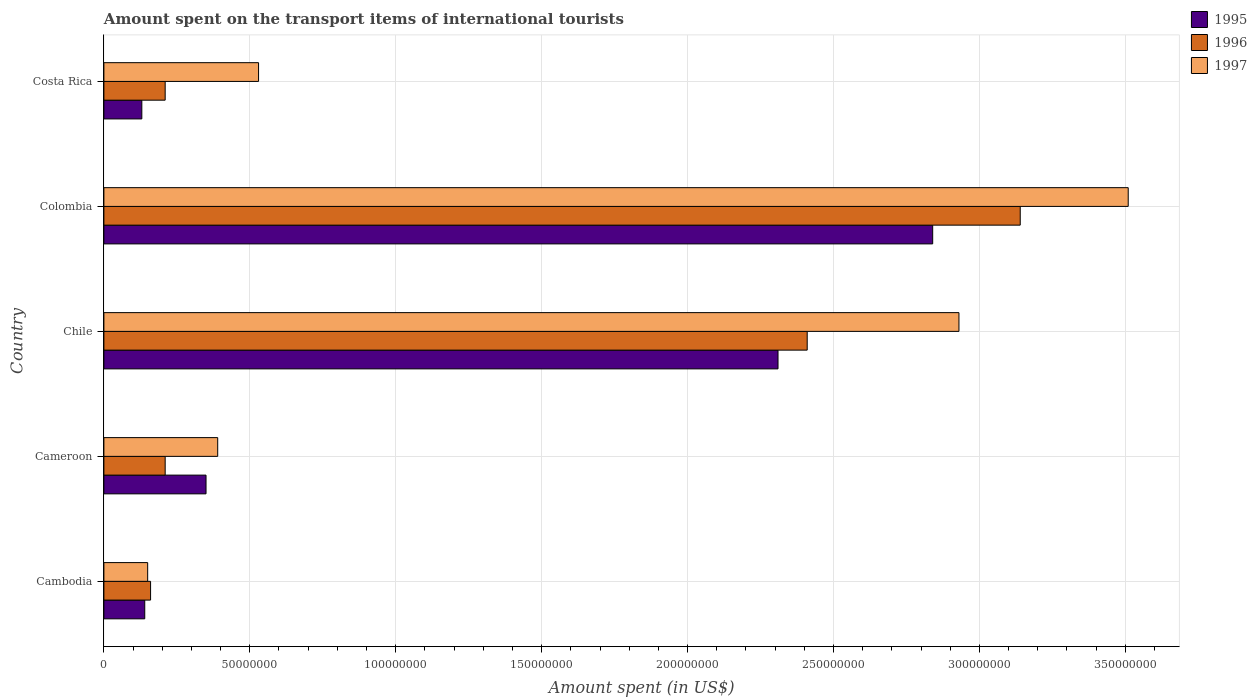How many different coloured bars are there?
Your answer should be compact. 3. How many groups of bars are there?
Keep it short and to the point. 5. Are the number of bars per tick equal to the number of legend labels?
Provide a short and direct response. Yes. Are the number of bars on each tick of the Y-axis equal?
Your response must be concise. Yes. How many bars are there on the 2nd tick from the top?
Make the answer very short. 3. What is the label of the 3rd group of bars from the top?
Give a very brief answer. Chile. What is the amount spent on the transport items of international tourists in 1997 in Costa Rica?
Provide a short and direct response. 5.30e+07. Across all countries, what is the maximum amount spent on the transport items of international tourists in 1997?
Keep it short and to the point. 3.51e+08. Across all countries, what is the minimum amount spent on the transport items of international tourists in 1997?
Make the answer very short. 1.50e+07. What is the total amount spent on the transport items of international tourists in 1997 in the graph?
Provide a succinct answer. 7.51e+08. What is the difference between the amount spent on the transport items of international tourists in 1997 in Cambodia and that in Colombia?
Your answer should be very brief. -3.36e+08. What is the difference between the amount spent on the transport items of international tourists in 1997 in Chile and the amount spent on the transport items of international tourists in 1995 in Cambodia?
Your answer should be very brief. 2.79e+08. What is the average amount spent on the transport items of international tourists in 1996 per country?
Your response must be concise. 1.23e+08. What is the difference between the amount spent on the transport items of international tourists in 1995 and amount spent on the transport items of international tourists in 1997 in Chile?
Provide a short and direct response. -6.20e+07. What is the ratio of the amount spent on the transport items of international tourists in 1996 in Chile to that in Costa Rica?
Offer a terse response. 11.48. What is the difference between the highest and the second highest amount spent on the transport items of international tourists in 1997?
Make the answer very short. 5.80e+07. What is the difference between the highest and the lowest amount spent on the transport items of international tourists in 1997?
Make the answer very short. 3.36e+08. In how many countries, is the amount spent on the transport items of international tourists in 1996 greater than the average amount spent on the transport items of international tourists in 1996 taken over all countries?
Your answer should be compact. 2. Is the sum of the amount spent on the transport items of international tourists in 1996 in Cambodia and Chile greater than the maximum amount spent on the transport items of international tourists in 1995 across all countries?
Give a very brief answer. No. What does the 1st bar from the bottom in Cameroon represents?
Give a very brief answer. 1995. How many bars are there?
Give a very brief answer. 15. What is the difference between two consecutive major ticks on the X-axis?
Your answer should be compact. 5.00e+07. Does the graph contain grids?
Your response must be concise. Yes. How many legend labels are there?
Ensure brevity in your answer.  3. What is the title of the graph?
Give a very brief answer. Amount spent on the transport items of international tourists. Does "2006" appear as one of the legend labels in the graph?
Your answer should be very brief. No. What is the label or title of the X-axis?
Your answer should be compact. Amount spent (in US$). What is the label or title of the Y-axis?
Keep it short and to the point. Country. What is the Amount spent (in US$) of 1995 in Cambodia?
Your answer should be very brief. 1.40e+07. What is the Amount spent (in US$) in 1996 in Cambodia?
Your response must be concise. 1.60e+07. What is the Amount spent (in US$) of 1997 in Cambodia?
Offer a very short reply. 1.50e+07. What is the Amount spent (in US$) in 1995 in Cameroon?
Offer a terse response. 3.50e+07. What is the Amount spent (in US$) of 1996 in Cameroon?
Your answer should be very brief. 2.10e+07. What is the Amount spent (in US$) of 1997 in Cameroon?
Offer a terse response. 3.90e+07. What is the Amount spent (in US$) in 1995 in Chile?
Your answer should be very brief. 2.31e+08. What is the Amount spent (in US$) in 1996 in Chile?
Ensure brevity in your answer.  2.41e+08. What is the Amount spent (in US$) in 1997 in Chile?
Offer a terse response. 2.93e+08. What is the Amount spent (in US$) in 1995 in Colombia?
Provide a short and direct response. 2.84e+08. What is the Amount spent (in US$) in 1996 in Colombia?
Offer a terse response. 3.14e+08. What is the Amount spent (in US$) of 1997 in Colombia?
Offer a terse response. 3.51e+08. What is the Amount spent (in US$) of 1995 in Costa Rica?
Ensure brevity in your answer.  1.30e+07. What is the Amount spent (in US$) in 1996 in Costa Rica?
Your response must be concise. 2.10e+07. What is the Amount spent (in US$) in 1997 in Costa Rica?
Your response must be concise. 5.30e+07. Across all countries, what is the maximum Amount spent (in US$) in 1995?
Give a very brief answer. 2.84e+08. Across all countries, what is the maximum Amount spent (in US$) of 1996?
Your answer should be compact. 3.14e+08. Across all countries, what is the maximum Amount spent (in US$) in 1997?
Offer a very short reply. 3.51e+08. Across all countries, what is the minimum Amount spent (in US$) in 1995?
Offer a terse response. 1.30e+07. Across all countries, what is the minimum Amount spent (in US$) of 1996?
Offer a terse response. 1.60e+07. Across all countries, what is the minimum Amount spent (in US$) of 1997?
Offer a terse response. 1.50e+07. What is the total Amount spent (in US$) in 1995 in the graph?
Your response must be concise. 5.77e+08. What is the total Amount spent (in US$) in 1996 in the graph?
Offer a very short reply. 6.13e+08. What is the total Amount spent (in US$) of 1997 in the graph?
Keep it short and to the point. 7.51e+08. What is the difference between the Amount spent (in US$) of 1995 in Cambodia and that in Cameroon?
Offer a very short reply. -2.10e+07. What is the difference between the Amount spent (in US$) in 1996 in Cambodia and that in Cameroon?
Offer a terse response. -5.00e+06. What is the difference between the Amount spent (in US$) of 1997 in Cambodia and that in Cameroon?
Your answer should be compact. -2.40e+07. What is the difference between the Amount spent (in US$) in 1995 in Cambodia and that in Chile?
Offer a terse response. -2.17e+08. What is the difference between the Amount spent (in US$) in 1996 in Cambodia and that in Chile?
Your answer should be very brief. -2.25e+08. What is the difference between the Amount spent (in US$) of 1997 in Cambodia and that in Chile?
Provide a succinct answer. -2.78e+08. What is the difference between the Amount spent (in US$) in 1995 in Cambodia and that in Colombia?
Offer a very short reply. -2.70e+08. What is the difference between the Amount spent (in US$) in 1996 in Cambodia and that in Colombia?
Offer a terse response. -2.98e+08. What is the difference between the Amount spent (in US$) of 1997 in Cambodia and that in Colombia?
Keep it short and to the point. -3.36e+08. What is the difference between the Amount spent (in US$) in 1996 in Cambodia and that in Costa Rica?
Provide a succinct answer. -5.00e+06. What is the difference between the Amount spent (in US$) in 1997 in Cambodia and that in Costa Rica?
Your answer should be very brief. -3.80e+07. What is the difference between the Amount spent (in US$) of 1995 in Cameroon and that in Chile?
Offer a terse response. -1.96e+08. What is the difference between the Amount spent (in US$) of 1996 in Cameroon and that in Chile?
Your response must be concise. -2.20e+08. What is the difference between the Amount spent (in US$) in 1997 in Cameroon and that in Chile?
Offer a terse response. -2.54e+08. What is the difference between the Amount spent (in US$) in 1995 in Cameroon and that in Colombia?
Ensure brevity in your answer.  -2.49e+08. What is the difference between the Amount spent (in US$) of 1996 in Cameroon and that in Colombia?
Your answer should be very brief. -2.93e+08. What is the difference between the Amount spent (in US$) in 1997 in Cameroon and that in Colombia?
Offer a very short reply. -3.12e+08. What is the difference between the Amount spent (in US$) of 1995 in Cameroon and that in Costa Rica?
Your response must be concise. 2.20e+07. What is the difference between the Amount spent (in US$) of 1997 in Cameroon and that in Costa Rica?
Offer a very short reply. -1.40e+07. What is the difference between the Amount spent (in US$) of 1995 in Chile and that in Colombia?
Ensure brevity in your answer.  -5.30e+07. What is the difference between the Amount spent (in US$) in 1996 in Chile and that in Colombia?
Give a very brief answer. -7.30e+07. What is the difference between the Amount spent (in US$) of 1997 in Chile and that in Colombia?
Your answer should be very brief. -5.80e+07. What is the difference between the Amount spent (in US$) of 1995 in Chile and that in Costa Rica?
Offer a very short reply. 2.18e+08. What is the difference between the Amount spent (in US$) in 1996 in Chile and that in Costa Rica?
Your answer should be compact. 2.20e+08. What is the difference between the Amount spent (in US$) in 1997 in Chile and that in Costa Rica?
Ensure brevity in your answer.  2.40e+08. What is the difference between the Amount spent (in US$) of 1995 in Colombia and that in Costa Rica?
Make the answer very short. 2.71e+08. What is the difference between the Amount spent (in US$) of 1996 in Colombia and that in Costa Rica?
Offer a terse response. 2.93e+08. What is the difference between the Amount spent (in US$) of 1997 in Colombia and that in Costa Rica?
Your answer should be very brief. 2.98e+08. What is the difference between the Amount spent (in US$) of 1995 in Cambodia and the Amount spent (in US$) of 1996 in Cameroon?
Provide a succinct answer. -7.00e+06. What is the difference between the Amount spent (in US$) of 1995 in Cambodia and the Amount spent (in US$) of 1997 in Cameroon?
Give a very brief answer. -2.50e+07. What is the difference between the Amount spent (in US$) of 1996 in Cambodia and the Amount spent (in US$) of 1997 in Cameroon?
Offer a very short reply. -2.30e+07. What is the difference between the Amount spent (in US$) of 1995 in Cambodia and the Amount spent (in US$) of 1996 in Chile?
Make the answer very short. -2.27e+08. What is the difference between the Amount spent (in US$) of 1995 in Cambodia and the Amount spent (in US$) of 1997 in Chile?
Provide a succinct answer. -2.79e+08. What is the difference between the Amount spent (in US$) in 1996 in Cambodia and the Amount spent (in US$) in 1997 in Chile?
Offer a terse response. -2.77e+08. What is the difference between the Amount spent (in US$) of 1995 in Cambodia and the Amount spent (in US$) of 1996 in Colombia?
Provide a succinct answer. -3.00e+08. What is the difference between the Amount spent (in US$) of 1995 in Cambodia and the Amount spent (in US$) of 1997 in Colombia?
Your answer should be very brief. -3.37e+08. What is the difference between the Amount spent (in US$) in 1996 in Cambodia and the Amount spent (in US$) in 1997 in Colombia?
Your response must be concise. -3.35e+08. What is the difference between the Amount spent (in US$) in 1995 in Cambodia and the Amount spent (in US$) in 1996 in Costa Rica?
Ensure brevity in your answer.  -7.00e+06. What is the difference between the Amount spent (in US$) of 1995 in Cambodia and the Amount spent (in US$) of 1997 in Costa Rica?
Ensure brevity in your answer.  -3.90e+07. What is the difference between the Amount spent (in US$) in 1996 in Cambodia and the Amount spent (in US$) in 1997 in Costa Rica?
Make the answer very short. -3.70e+07. What is the difference between the Amount spent (in US$) of 1995 in Cameroon and the Amount spent (in US$) of 1996 in Chile?
Ensure brevity in your answer.  -2.06e+08. What is the difference between the Amount spent (in US$) of 1995 in Cameroon and the Amount spent (in US$) of 1997 in Chile?
Make the answer very short. -2.58e+08. What is the difference between the Amount spent (in US$) in 1996 in Cameroon and the Amount spent (in US$) in 1997 in Chile?
Provide a short and direct response. -2.72e+08. What is the difference between the Amount spent (in US$) of 1995 in Cameroon and the Amount spent (in US$) of 1996 in Colombia?
Your answer should be very brief. -2.79e+08. What is the difference between the Amount spent (in US$) in 1995 in Cameroon and the Amount spent (in US$) in 1997 in Colombia?
Ensure brevity in your answer.  -3.16e+08. What is the difference between the Amount spent (in US$) in 1996 in Cameroon and the Amount spent (in US$) in 1997 in Colombia?
Ensure brevity in your answer.  -3.30e+08. What is the difference between the Amount spent (in US$) of 1995 in Cameroon and the Amount spent (in US$) of 1996 in Costa Rica?
Offer a very short reply. 1.40e+07. What is the difference between the Amount spent (in US$) of 1995 in Cameroon and the Amount spent (in US$) of 1997 in Costa Rica?
Your response must be concise. -1.80e+07. What is the difference between the Amount spent (in US$) in 1996 in Cameroon and the Amount spent (in US$) in 1997 in Costa Rica?
Offer a very short reply. -3.20e+07. What is the difference between the Amount spent (in US$) in 1995 in Chile and the Amount spent (in US$) in 1996 in Colombia?
Your response must be concise. -8.30e+07. What is the difference between the Amount spent (in US$) of 1995 in Chile and the Amount spent (in US$) of 1997 in Colombia?
Ensure brevity in your answer.  -1.20e+08. What is the difference between the Amount spent (in US$) of 1996 in Chile and the Amount spent (in US$) of 1997 in Colombia?
Offer a terse response. -1.10e+08. What is the difference between the Amount spent (in US$) of 1995 in Chile and the Amount spent (in US$) of 1996 in Costa Rica?
Give a very brief answer. 2.10e+08. What is the difference between the Amount spent (in US$) in 1995 in Chile and the Amount spent (in US$) in 1997 in Costa Rica?
Make the answer very short. 1.78e+08. What is the difference between the Amount spent (in US$) of 1996 in Chile and the Amount spent (in US$) of 1997 in Costa Rica?
Your response must be concise. 1.88e+08. What is the difference between the Amount spent (in US$) in 1995 in Colombia and the Amount spent (in US$) in 1996 in Costa Rica?
Give a very brief answer. 2.63e+08. What is the difference between the Amount spent (in US$) in 1995 in Colombia and the Amount spent (in US$) in 1997 in Costa Rica?
Your response must be concise. 2.31e+08. What is the difference between the Amount spent (in US$) in 1996 in Colombia and the Amount spent (in US$) in 1997 in Costa Rica?
Your answer should be very brief. 2.61e+08. What is the average Amount spent (in US$) in 1995 per country?
Provide a short and direct response. 1.15e+08. What is the average Amount spent (in US$) of 1996 per country?
Make the answer very short. 1.23e+08. What is the average Amount spent (in US$) in 1997 per country?
Your response must be concise. 1.50e+08. What is the difference between the Amount spent (in US$) of 1996 and Amount spent (in US$) of 1997 in Cambodia?
Your answer should be compact. 1.00e+06. What is the difference between the Amount spent (in US$) of 1995 and Amount spent (in US$) of 1996 in Cameroon?
Your response must be concise. 1.40e+07. What is the difference between the Amount spent (in US$) of 1996 and Amount spent (in US$) of 1997 in Cameroon?
Offer a very short reply. -1.80e+07. What is the difference between the Amount spent (in US$) of 1995 and Amount spent (in US$) of 1996 in Chile?
Your answer should be compact. -1.00e+07. What is the difference between the Amount spent (in US$) of 1995 and Amount spent (in US$) of 1997 in Chile?
Your response must be concise. -6.20e+07. What is the difference between the Amount spent (in US$) in 1996 and Amount spent (in US$) in 1997 in Chile?
Make the answer very short. -5.20e+07. What is the difference between the Amount spent (in US$) in 1995 and Amount spent (in US$) in 1996 in Colombia?
Keep it short and to the point. -3.00e+07. What is the difference between the Amount spent (in US$) of 1995 and Amount spent (in US$) of 1997 in Colombia?
Keep it short and to the point. -6.70e+07. What is the difference between the Amount spent (in US$) in 1996 and Amount spent (in US$) in 1997 in Colombia?
Give a very brief answer. -3.70e+07. What is the difference between the Amount spent (in US$) of 1995 and Amount spent (in US$) of 1996 in Costa Rica?
Your answer should be compact. -8.00e+06. What is the difference between the Amount spent (in US$) in 1995 and Amount spent (in US$) in 1997 in Costa Rica?
Keep it short and to the point. -4.00e+07. What is the difference between the Amount spent (in US$) of 1996 and Amount spent (in US$) of 1997 in Costa Rica?
Offer a terse response. -3.20e+07. What is the ratio of the Amount spent (in US$) in 1996 in Cambodia to that in Cameroon?
Offer a very short reply. 0.76. What is the ratio of the Amount spent (in US$) of 1997 in Cambodia to that in Cameroon?
Ensure brevity in your answer.  0.38. What is the ratio of the Amount spent (in US$) of 1995 in Cambodia to that in Chile?
Your answer should be compact. 0.06. What is the ratio of the Amount spent (in US$) in 1996 in Cambodia to that in Chile?
Your answer should be very brief. 0.07. What is the ratio of the Amount spent (in US$) of 1997 in Cambodia to that in Chile?
Offer a very short reply. 0.05. What is the ratio of the Amount spent (in US$) in 1995 in Cambodia to that in Colombia?
Provide a succinct answer. 0.05. What is the ratio of the Amount spent (in US$) of 1996 in Cambodia to that in Colombia?
Offer a very short reply. 0.05. What is the ratio of the Amount spent (in US$) in 1997 in Cambodia to that in Colombia?
Give a very brief answer. 0.04. What is the ratio of the Amount spent (in US$) in 1996 in Cambodia to that in Costa Rica?
Make the answer very short. 0.76. What is the ratio of the Amount spent (in US$) in 1997 in Cambodia to that in Costa Rica?
Provide a short and direct response. 0.28. What is the ratio of the Amount spent (in US$) of 1995 in Cameroon to that in Chile?
Give a very brief answer. 0.15. What is the ratio of the Amount spent (in US$) of 1996 in Cameroon to that in Chile?
Give a very brief answer. 0.09. What is the ratio of the Amount spent (in US$) in 1997 in Cameroon to that in Chile?
Ensure brevity in your answer.  0.13. What is the ratio of the Amount spent (in US$) in 1995 in Cameroon to that in Colombia?
Provide a succinct answer. 0.12. What is the ratio of the Amount spent (in US$) in 1996 in Cameroon to that in Colombia?
Make the answer very short. 0.07. What is the ratio of the Amount spent (in US$) of 1995 in Cameroon to that in Costa Rica?
Provide a succinct answer. 2.69. What is the ratio of the Amount spent (in US$) of 1996 in Cameroon to that in Costa Rica?
Keep it short and to the point. 1. What is the ratio of the Amount spent (in US$) in 1997 in Cameroon to that in Costa Rica?
Keep it short and to the point. 0.74. What is the ratio of the Amount spent (in US$) of 1995 in Chile to that in Colombia?
Keep it short and to the point. 0.81. What is the ratio of the Amount spent (in US$) of 1996 in Chile to that in Colombia?
Give a very brief answer. 0.77. What is the ratio of the Amount spent (in US$) of 1997 in Chile to that in Colombia?
Give a very brief answer. 0.83. What is the ratio of the Amount spent (in US$) in 1995 in Chile to that in Costa Rica?
Ensure brevity in your answer.  17.77. What is the ratio of the Amount spent (in US$) in 1996 in Chile to that in Costa Rica?
Give a very brief answer. 11.48. What is the ratio of the Amount spent (in US$) of 1997 in Chile to that in Costa Rica?
Your answer should be compact. 5.53. What is the ratio of the Amount spent (in US$) in 1995 in Colombia to that in Costa Rica?
Keep it short and to the point. 21.85. What is the ratio of the Amount spent (in US$) in 1996 in Colombia to that in Costa Rica?
Offer a very short reply. 14.95. What is the ratio of the Amount spent (in US$) in 1997 in Colombia to that in Costa Rica?
Your answer should be very brief. 6.62. What is the difference between the highest and the second highest Amount spent (in US$) of 1995?
Provide a succinct answer. 5.30e+07. What is the difference between the highest and the second highest Amount spent (in US$) of 1996?
Make the answer very short. 7.30e+07. What is the difference between the highest and the second highest Amount spent (in US$) of 1997?
Give a very brief answer. 5.80e+07. What is the difference between the highest and the lowest Amount spent (in US$) in 1995?
Ensure brevity in your answer.  2.71e+08. What is the difference between the highest and the lowest Amount spent (in US$) of 1996?
Offer a very short reply. 2.98e+08. What is the difference between the highest and the lowest Amount spent (in US$) of 1997?
Keep it short and to the point. 3.36e+08. 